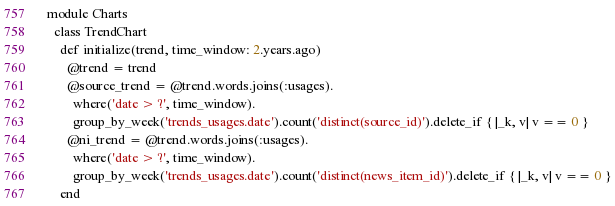Convert code to text. <code><loc_0><loc_0><loc_500><loc_500><_Ruby_>module Charts
  class TrendChart
    def initialize(trend, time_window: 2.years.ago)
      @trend = trend
      @source_trend = @trend.words.joins(:usages).
        where('date > ?', time_window).
        group_by_week('trends_usages.date').count('distinct(source_id)').delete_if { |_k, v| v == 0 }
      @ni_trend = @trend.words.joins(:usages).
        where('date > ?', time_window).
        group_by_week('trends_usages.date').count('distinct(news_item_id)').delete_if { |_k, v| v == 0 }
    end
</code> 